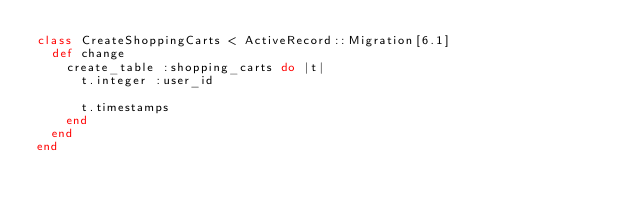Convert code to text. <code><loc_0><loc_0><loc_500><loc_500><_Ruby_>class CreateShoppingCarts < ActiveRecord::Migration[6.1]
  def change
    create_table :shopping_carts do |t|
      t.integer :user_id

      t.timestamps
    end
  end
end
</code> 